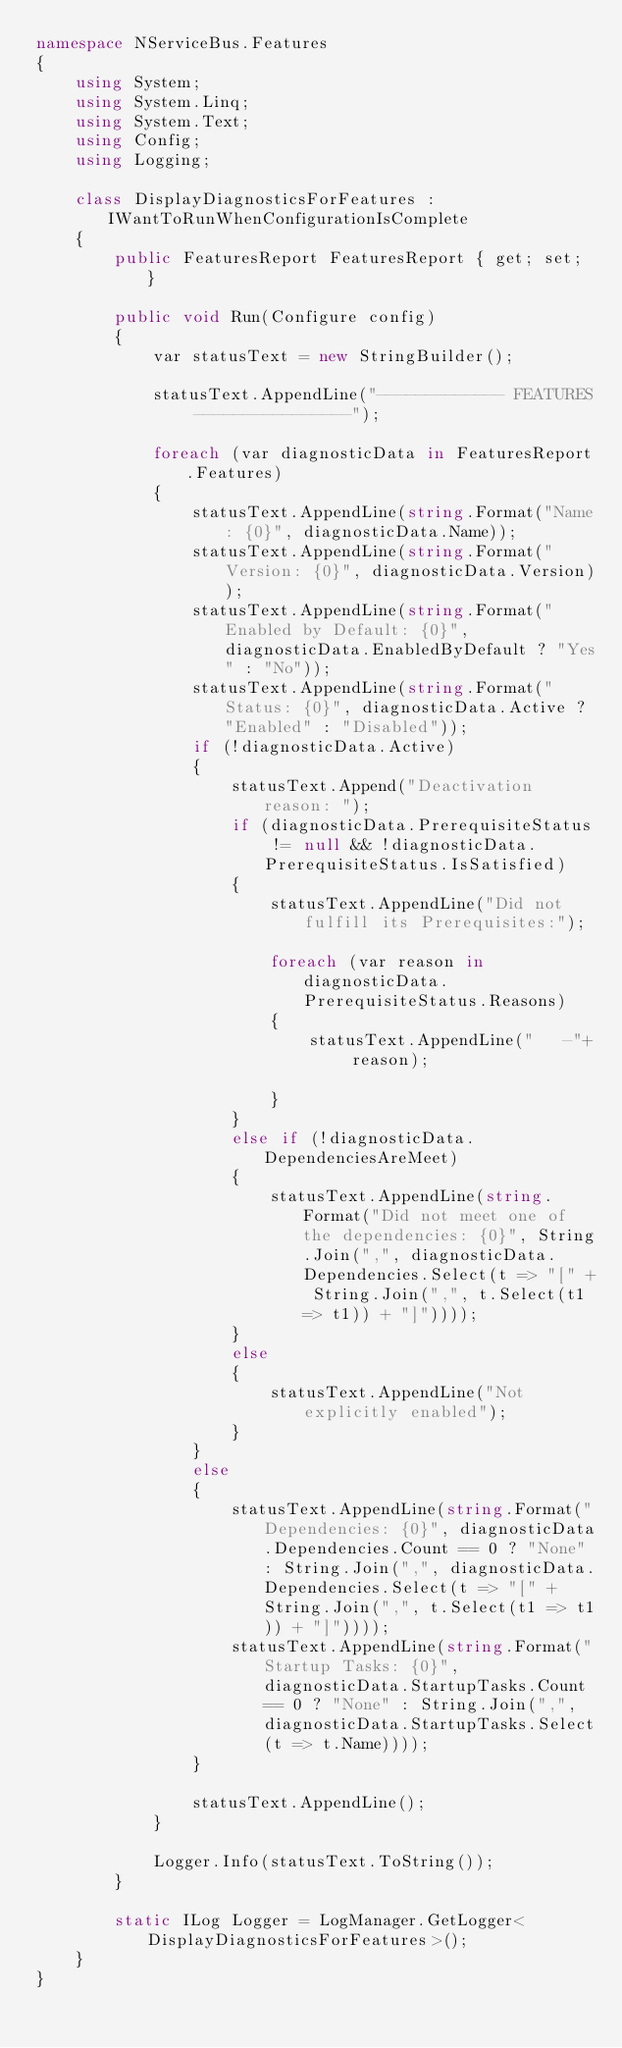<code> <loc_0><loc_0><loc_500><loc_500><_C#_>namespace NServiceBus.Features
{
    using System;
    using System.Linq;
    using System.Text;
    using Config;
    using Logging;

    class DisplayDiagnosticsForFeatures : IWantToRunWhenConfigurationIsComplete
    {
        public FeaturesReport FeaturesReport { get; set; }

        public void Run(Configure config)
        {
            var statusText = new StringBuilder();

            statusText.AppendLine("------------- FEATURES ----------------");

            foreach (var diagnosticData in FeaturesReport.Features)
            {
                statusText.AppendLine(string.Format("Name: {0}", diagnosticData.Name));
                statusText.AppendLine(string.Format("Version: {0}", diagnosticData.Version));
                statusText.AppendLine(string.Format("Enabled by Default: {0}", diagnosticData.EnabledByDefault ? "Yes" : "No"));
                statusText.AppendLine(string.Format("Status: {0}", diagnosticData.Active ? "Enabled" : "Disabled"));
                if (!diagnosticData.Active)
                {
                    statusText.Append("Deactivation reason: ");
                    if (diagnosticData.PrerequisiteStatus != null && !diagnosticData.PrerequisiteStatus.IsSatisfied)
                    {
                        statusText.AppendLine("Did not fulfill its Prerequisites:");

                        foreach (var reason in diagnosticData.PrerequisiteStatus.Reasons)
                        {
                            statusText.AppendLine("   -"+ reason);
                            
                        }
                    } 
                    else if (!diagnosticData.DependenciesAreMeet)
                    {
                        statusText.AppendLine(string.Format("Did not meet one of the dependencies: {0}", String.Join(",", diagnosticData.Dependencies.Select(t => "[" + String.Join(",", t.Select(t1 => t1)) + "]"))));
                    }
                    else
                    {
                        statusText.AppendLine("Not explicitly enabled");            
                    }
                }
                else
                {
                    statusText.AppendLine(string.Format("Dependencies: {0}", diagnosticData.Dependencies.Count == 0 ? "None" : String.Join(",", diagnosticData.Dependencies.Select(t => "[" + String.Join(",", t.Select(t1 => t1)) + "]"))));
                    statusText.AppendLine(string.Format("Startup Tasks: {0}", diagnosticData.StartupTasks.Count == 0 ? "None" : String.Join(",", diagnosticData.StartupTasks.Select(t => t.Name))));
                }

                statusText.AppendLine();
            }

            Logger.Info(statusText.ToString());
        }

        static ILog Logger = LogManager.GetLogger<DisplayDiagnosticsForFeatures>();
    }
}</code> 